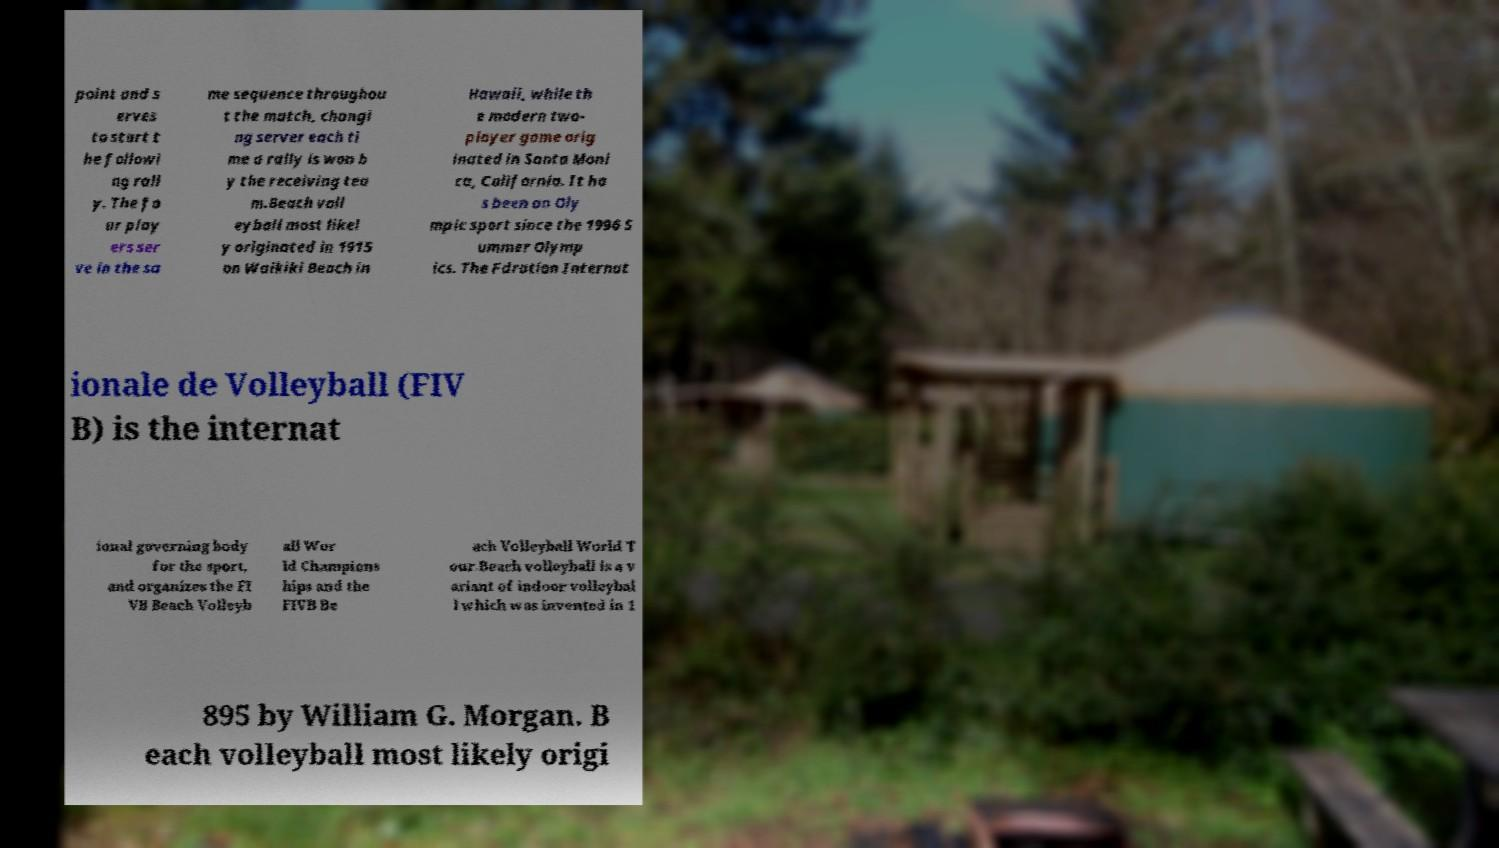There's text embedded in this image that I need extracted. Can you transcribe it verbatim? point and s erves to start t he followi ng rall y. The fo ur play ers ser ve in the sa me sequence throughou t the match, changi ng server each ti me a rally is won b y the receiving tea m.Beach voll eyball most likel y originated in 1915 on Waikiki Beach in Hawaii, while th e modern two- player game orig inated in Santa Moni ca, California. It ha s been an Oly mpic sport since the 1996 S ummer Olymp ics. The Fdration Internat ionale de Volleyball (FIV B) is the internat ional governing body for the sport, and organizes the FI VB Beach Volleyb all Wor ld Champions hips and the FIVB Be ach Volleyball World T our.Beach volleyball is a v ariant of indoor volleybal l which was invented in 1 895 by William G. Morgan. B each volleyball most likely origi 